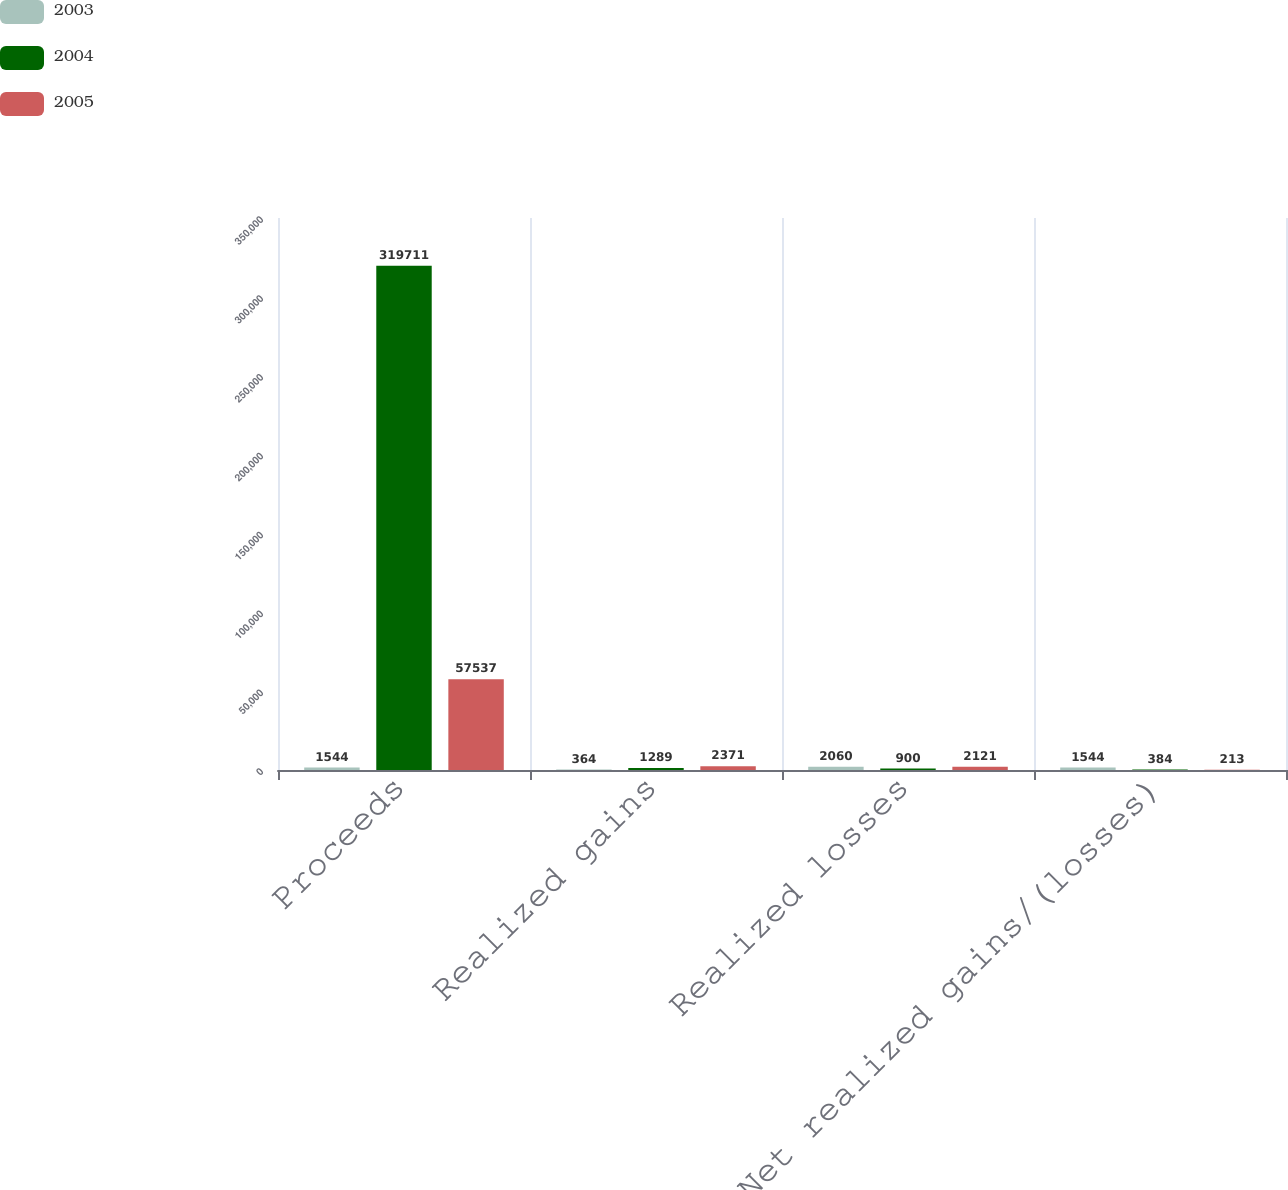<chart> <loc_0><loc_0><loc_500><loc_500><stacked_bar_chart><ecel><fcel>Proceeds<fcel>Realized gains<fcel>Realized losses<fcel>Net realized gains/(losses)<nl><fcel>2003<fcel>1544<fcel>364<fcel>2060<fcel>1544<nl><fcel>2004<fcel>319711<fcel>1289<fcel>900<fcel>384<nl><fcel>2005<fcel>57537<fcel>2371<fcel>2121<fcel>213<nl></chart> 